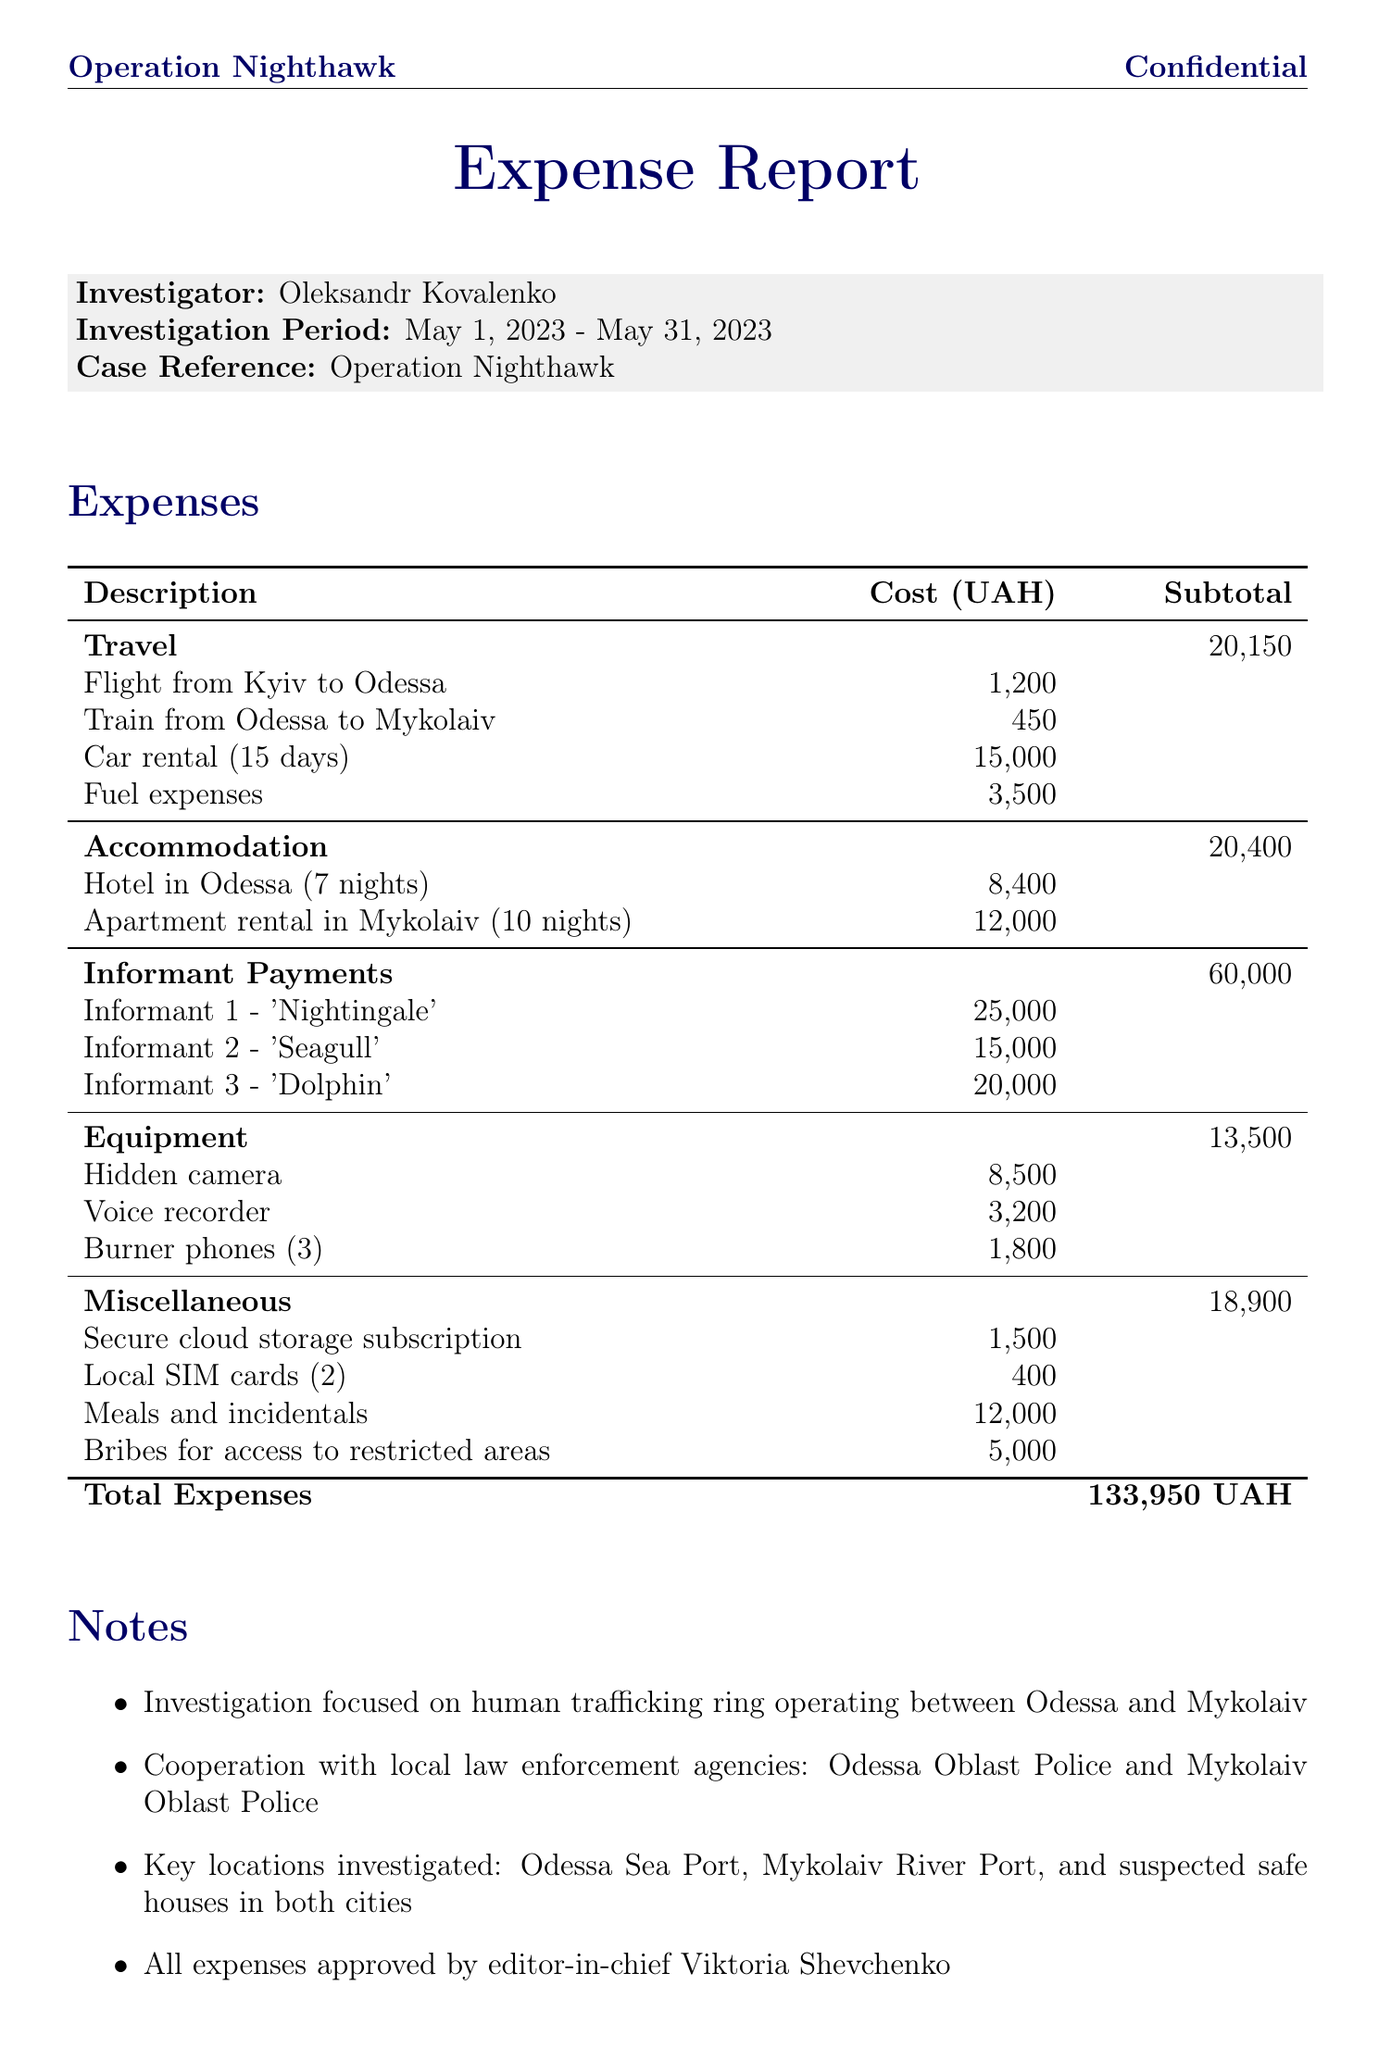What is the investigation period? The investigation period is the timeframe during which the investigation was conducted, mentioned at the beginning of the document.
Answer: May 1, 2023 - May 31, 2023 Who is the investigator? The investigator's name is listed prominently in the document.
Answer: Oleksandr Kovalenko What is the total expense amount? The total expense is found at the end of the expenses table.
Answer: 133950 UAH How much was spent on informant payments? The total for informant payments is calculated from the individual payments listed in the expenses section.
Answer: 60000 UAH What is the cost of the hidden camera? The cost of the hidden camera is specified under the equipment category in the expenses section.
Answer: 8500 UAH What was the cost for hotel accommodation in Odessa? This cost is explicitly detailed in the accommodation section of the document.
Answer: 8400 UAH Which two cities were investigated? The document mentions the main locations of the investigation that provide the city names.
Answer: Odessa and Mykolaiv What type of document is this? This document details the nature of the information presented, focused on expenses for an investigation.
Answer: Expense Report How many burner phones were purchased? The number of burner phones is mentioned in the equipment section of the expense report.
Answer: 3 